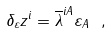<formula> <loc_0><loc_0><loc_500><loc_500>\delta _ { \varepsilon } z ^ { i } = \overline { \lambda } ^ { i A } \varepsilon _ { A } \ ,</formula> 